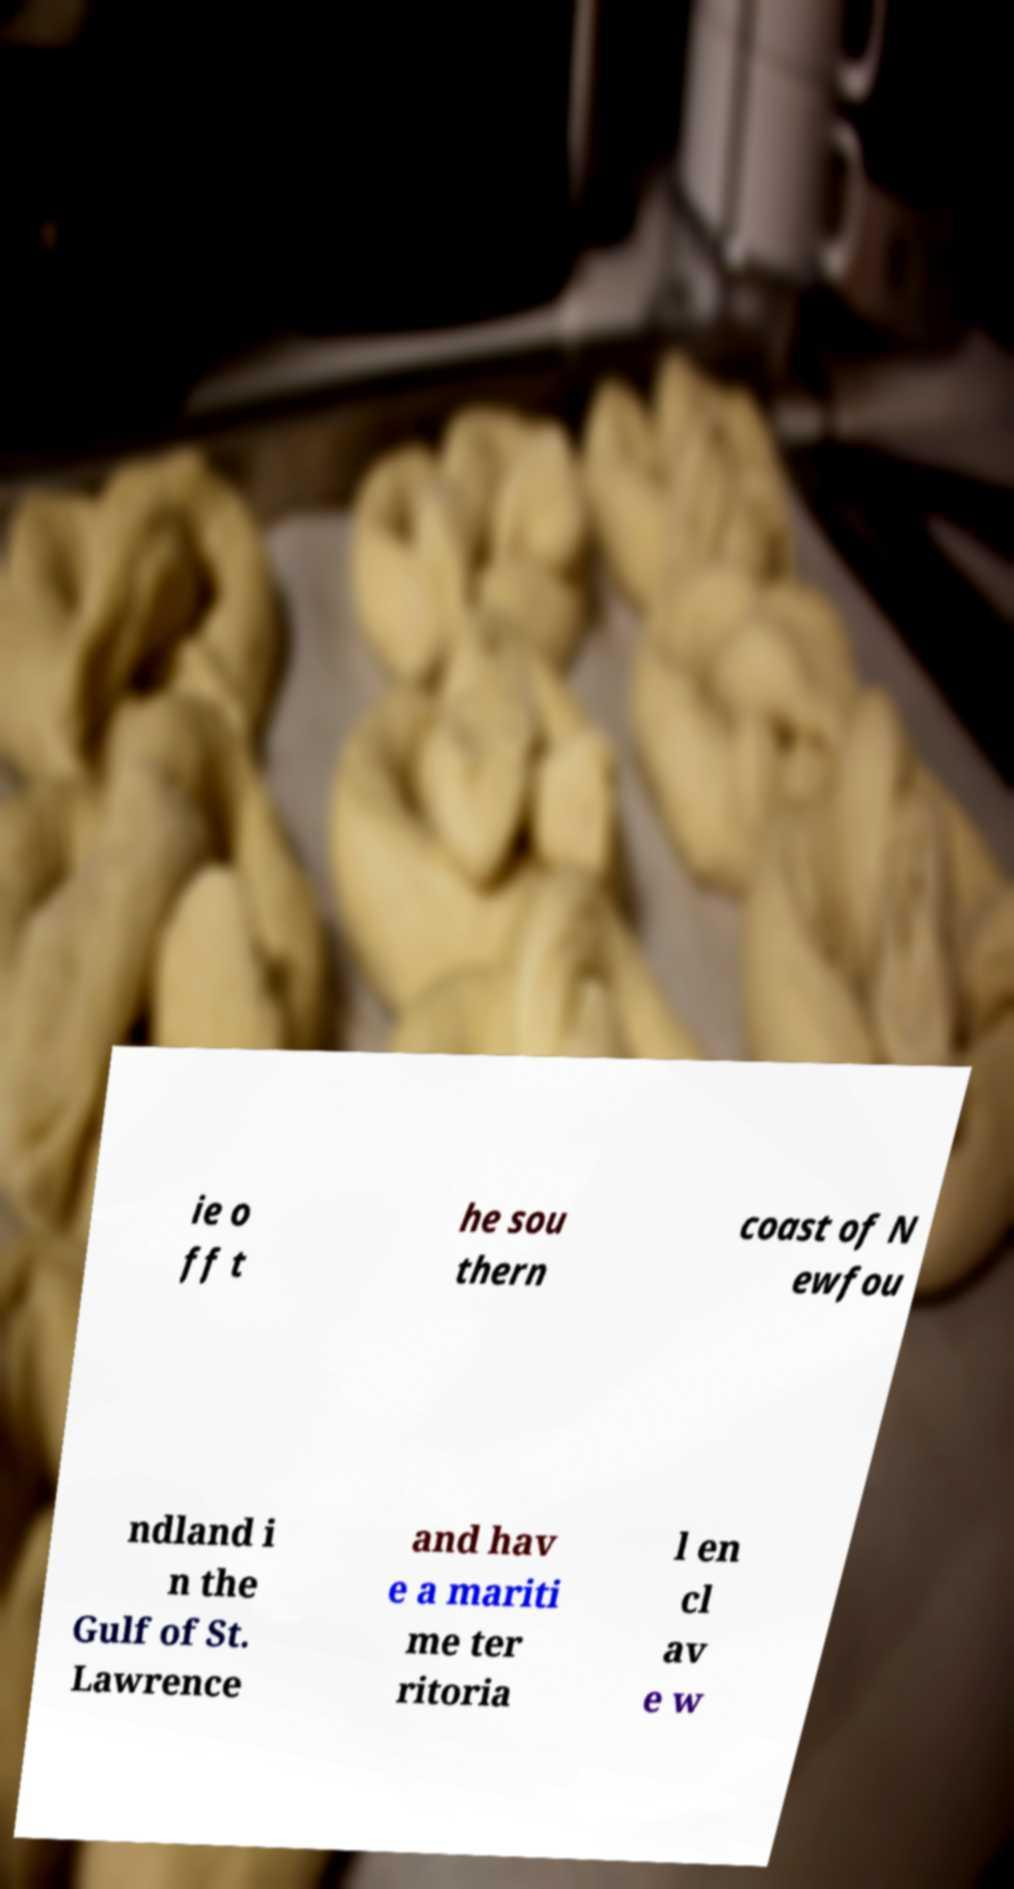For documentation purposes, I need the text within this image transcribed. Could you provide that? ie o ff t he sou thern coast of N ewfou ndland i n the Gulf of St. Lawrence and hav e a mariti me ter ritoria l en cl av e w 